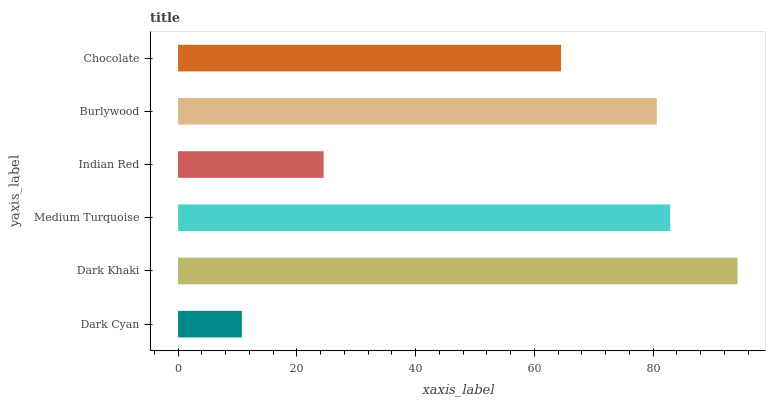Is Dark Cyan the minimum?
Answer yes or no. Yes. Is Dark Khaki the maximum?
Answer yes or no. Yes. Is Medium Turquoise the minimum?
Answer yes or no. No. Is Medium Turquoise the maximum?
Answer yes or no. No. Is Dark Khaki greater than Medium Turquoise?
Answer yes or no. Yes. Is Medium Turquoise less than Dark Khaki?
Answer yes or no. Yes. Is Medium Turquoise greater than Dark Khaki?
Answer yes or no. No. Is Dark Khaki less than Medium Turquoise?
Answer yes or no. No. Is Burlywood the high median?
Answer yes or no. Yes. Is Chocolate the low median?
Answer yes or no. Yes. Is Indian Red the high median?
Answer yes or no. No. Is Medium Turquoise the low median?
Answer yes or no. No. 